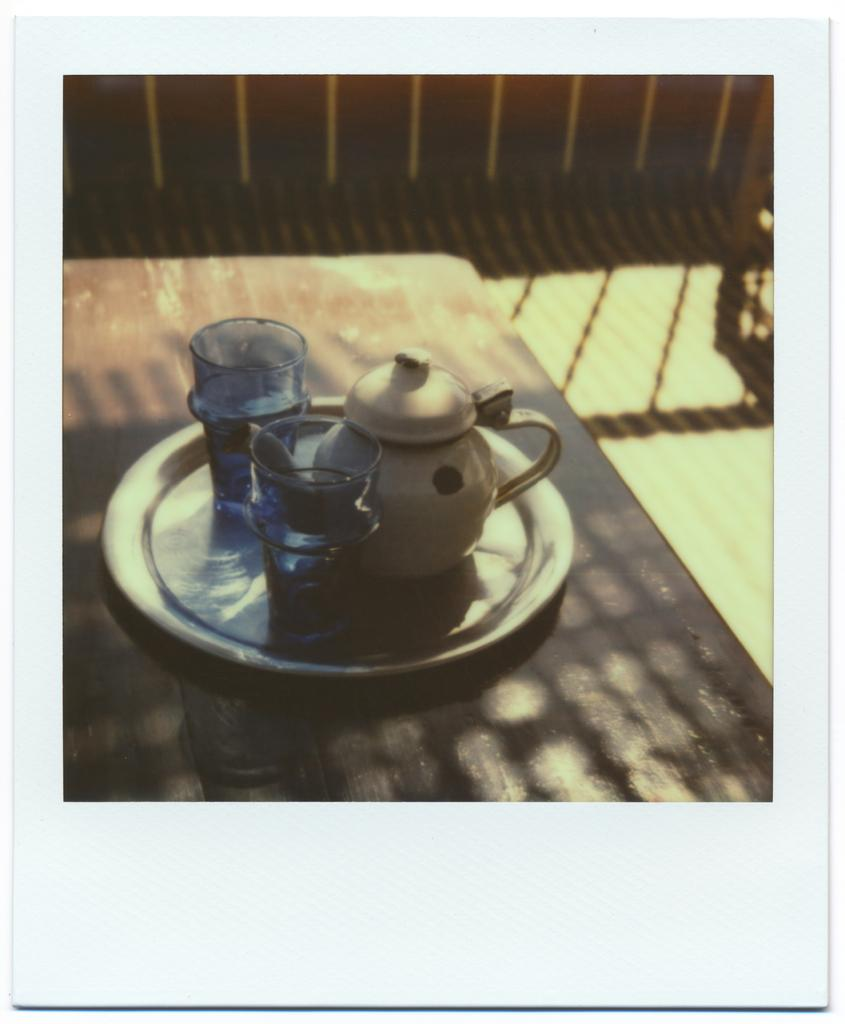What piece of furniture is present in the image? There is a table in the image. What is placed on the table? There is a plate on the table. What is on the plate? There are glasses on the plate. What other item can be seen in the image? There is a kettle in the image. What type of art is displayed on the arm in the image? There is no arm or art present in the image. 